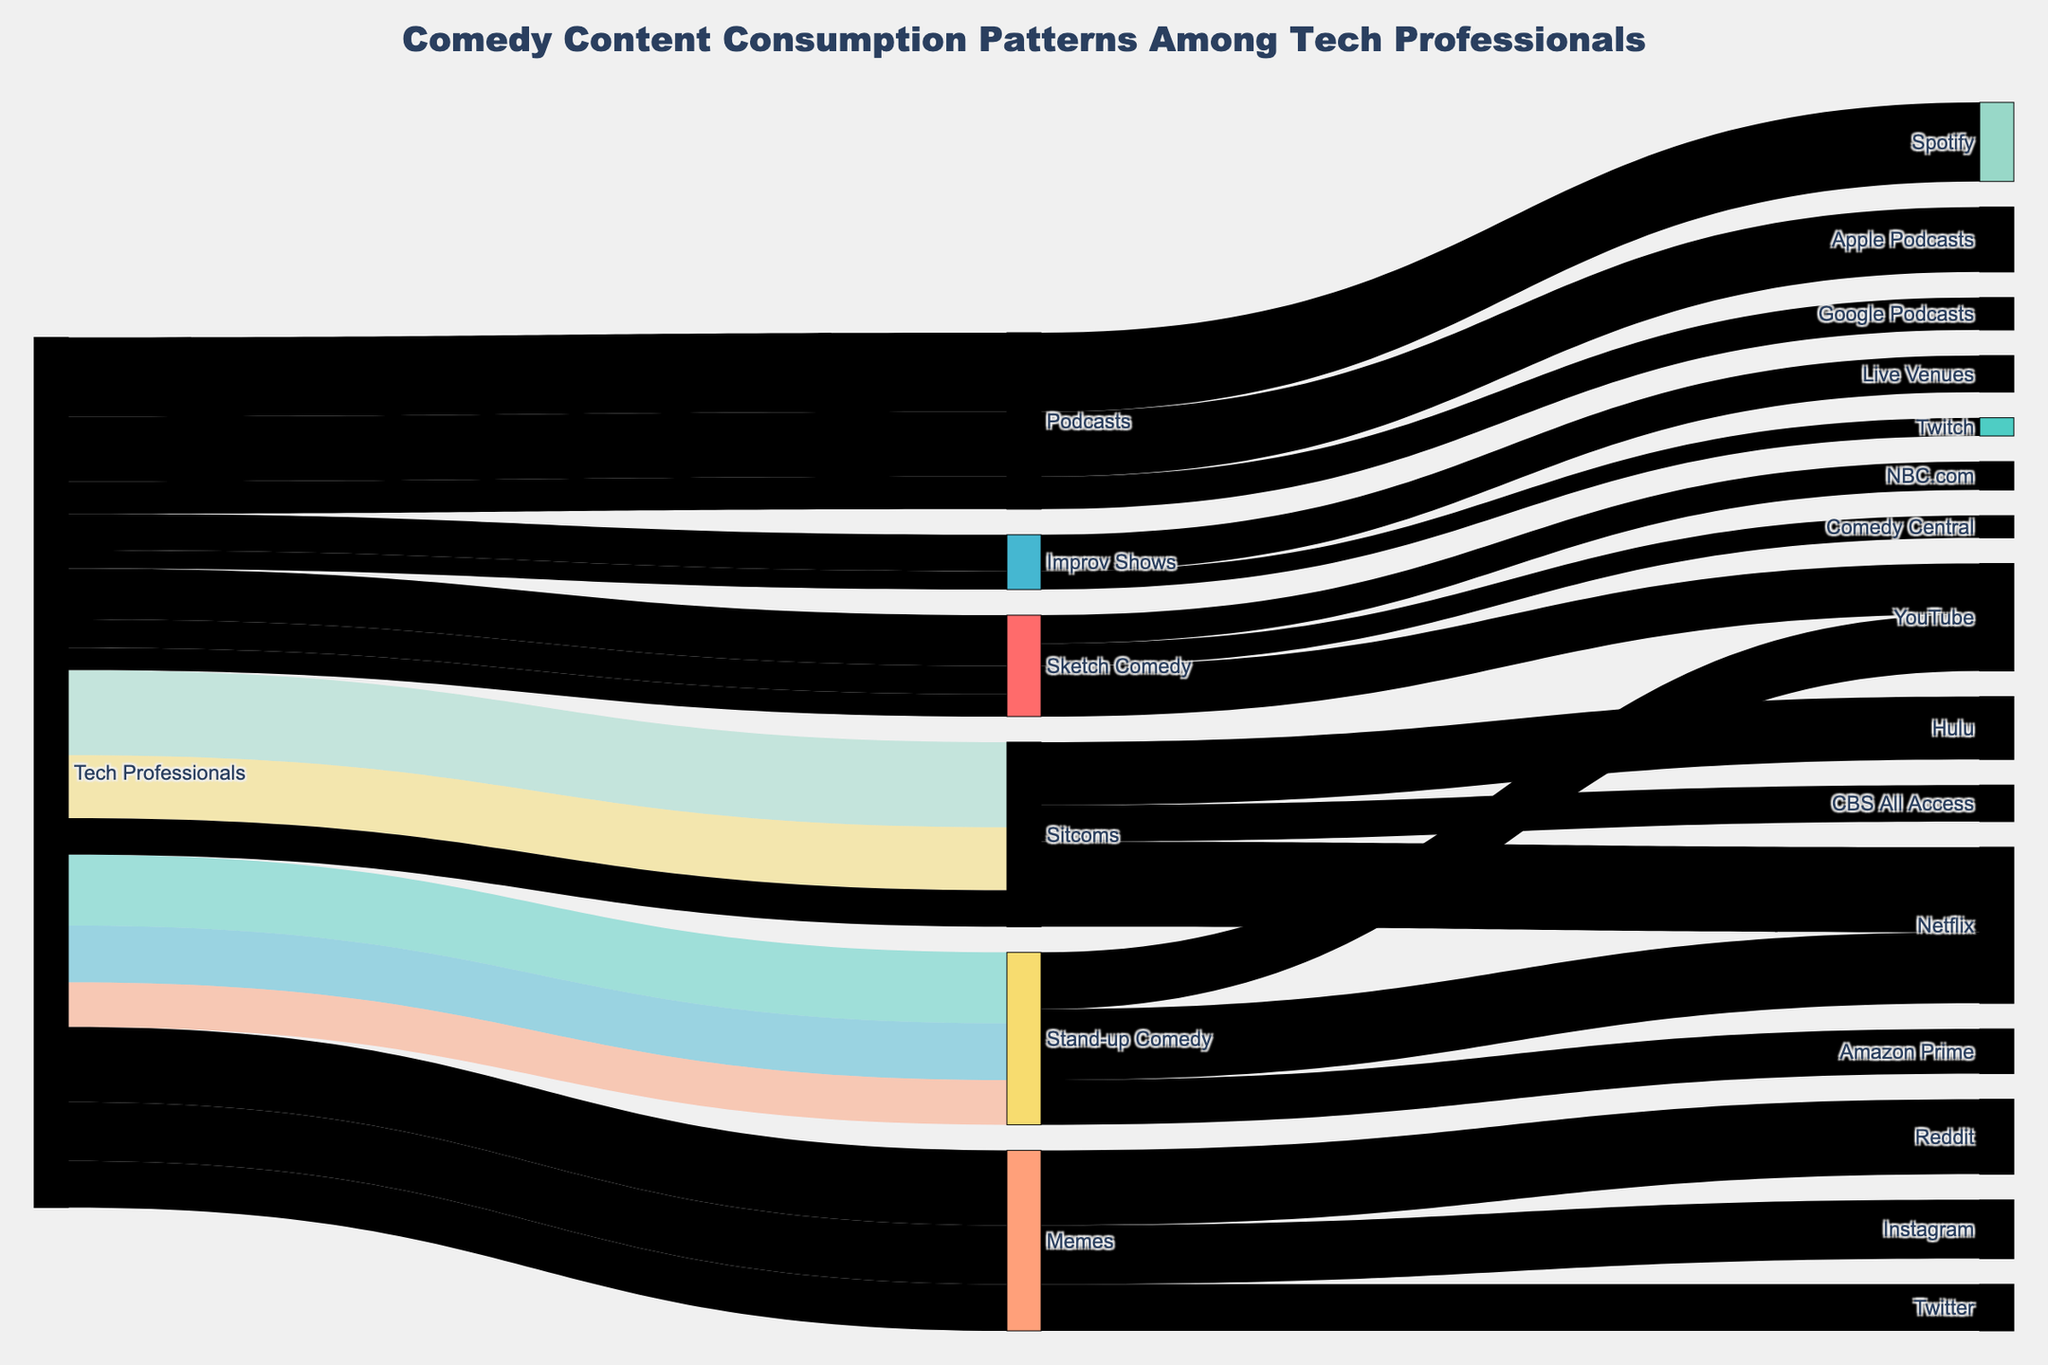How many tech professionals consume stand-up comedy on YouTube? To find the number of tech professionals consuming stand-up comedy on YouTube, locate the "Stand-up Comedy" node and follow the link to "YouTube" to read the consumption value.
Answer: 2,800 What's the total consumption of sitcoms across all platforms? To find the total consumption of sitcoms, sum the consumption values from Netflix, Hulu, and CBS All Access: 4,200 + 3,100 + 1,800.
Answer: 9,100 Which platform has the highest consumption of sketch comedy? To determine which platform has the highest consumption of sketch comedy, compare the consumption values of YouTube, NBC.com, and Comedy Central.
Answer: YouTube Compare the number of tech professionals consuming podcasts on Spotify versus Apple Podcasts. To compare, identify the consumption values for podcasts on Spotify (3,900) and Apple Podcasts (3,200) and determine which is higher.
Answer: Spotify What's the combined consumption of podcasts on Spotify and Google Podcasts? Add the consumption values for Spotify and Google Podcasts: 3,900 + 1,600.
Answer: 5,500 Identify which medium has the lowest total consumption across all platforms. Sum up the consumption for each medium across its platforms and compare: Stand-up Comedy (3,500 + 2,800 + 2,200), Sitcoms (4,200 + 3,100 + 1,800), Podcasts (3,900 + 3,200 + 1,600), Sketch Comedy (2,500 + 1,400 + 1,100), Improv Shows (1,800 + 900), Memes (3,700 + 2,900 + 2,300). Find the lowest total consumption.
Answer: Improv Shows What's the total consumption of all comedy content across all platforms? Add up all individual consumption values for tech professionals across all mediums and platforms.
Answer: 47,300 Compare the consumption of sitcoms on CBS All Access to the consumption of memes on Twitter. Locate the consumption values for sitcoms on CBS All Access (1,800) and memes on Twitter (2,300), then compare them to see which is higher.
Answer: Twitter How does the consumption of improv shows in live venues compare to comedy content on Twitch? Identify the consumption values for improv shows in live venues (1,800) and Twitch (900) and compare them.
Answer: Live Venues have higher consumption 